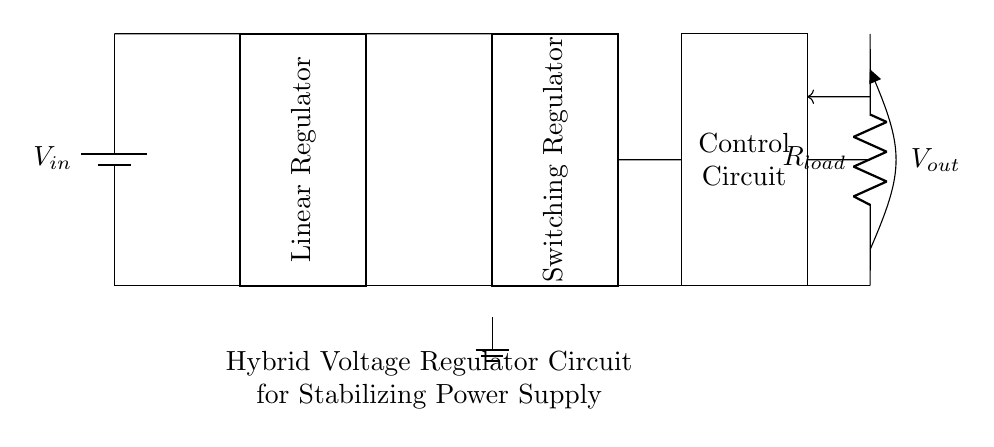What are the main components in this circuit? The main components of the hybrid voltage regulator circuit include a battery (input voltage), a linear regulator, a switching regulator, a control circuit, and a load resistor. Each of these components serves a specific function in regulating and stabilizing the output voltage.
Answer: battery, linear regulator, switching regulator, control circuit, load resistor What is the purpose of the linear regulator in this circuit? The linear regulator's role is to provide a stable output voltage by reducing the input voltage to a lower value while minimizing ripple. It efficiently regulates voltage by dissipating excess power as heat. The connection points before and after the regulator indicate its function in the circuit.
Answer: stabilize output voltage Which component receives input from the battery? The linear regulator directly receives input from the battery, as indicated by the connection at the top of the diagram where the input voltage flows into the linear regulator.
Answer: linear regulator How does feedback affect the output in this circuit? Feedback plays a crucial role in ensuring that the output voltage remains stable. The connection from the output (load resistor) back to the control circuit helps adjust the voltage to maintain regulation as load conditions change, enhancing overall circuit stability.
Answer: stabilizes voltage What distinguishes the switching regulator from the linear regulator? The switching regulator is distinguished by its efficiency; it converts input voltage to output voltage using high-frequency switching techniques instead of dissipative voltage drop. This allows it to handle larger variations in input voltage while producing less heat compared to the linear regulator.
Answer: efficiency What is the function of the control circuit? The control circuit monitors the output voltage and adjusts the operation of the linear and switching regulators based on the feedback to optimize performance, ensuring the output remains stable under varying load conditions.
Answer: regulates voltage What type of circuit is represented here? The circuit is a hybrid voltage regulator circuit, which utilizes both linear and switching regulation techniques to stabilize power supply in electronic devices, combining the advantages of both methods.
Answer: hybrid voltage regulator 